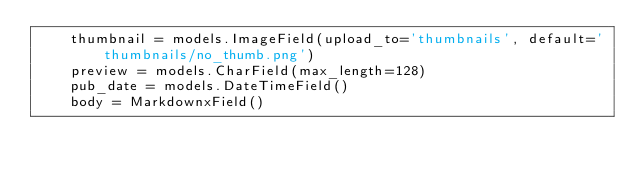Convert code to text. <code><loc_0><loc_0><loc_500><loc_500><_Python_>    thumbnail = models.ImageField(upload_to='thumbnails', default='thumbnails/no_thumb.png')
    preview = models.CharField(max_length=128)
    pub_date = models.DateTimeField()
    body = MarkdownxField()
</code> 